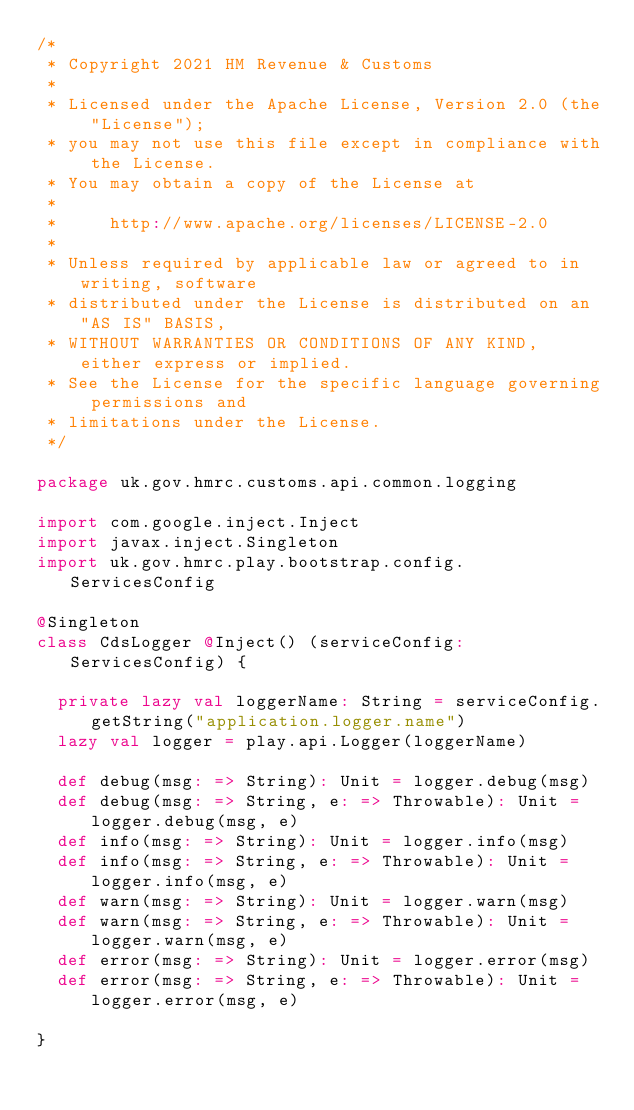<code> <loc_0><loc_0><loc_500><loc_500><_Scala_>/*
 * Copyright 2021 HM Revenue & Customs
 *
 * Licensed under the Apache License, Version 2.0 (the "License");
 * you may not use this file except in compliance with the License.
 * You may obtain a copy of the License at
 *
 *     http://www.apache.org/licenses/LICENSE-2.0
 *
 * Unless required by applicable law or agreed to in writing, software
 * distributed under the License is distributed on an "AS IS" BASIS,
 * WITHOUT WARRANTIES OR CONDITIONS OF ANY KIND, either express or implied.
 * See the License for the specific language governing permissions and
 * limitations under the License.
 */

package uk.gov.hmrc.customs.api.common.logging

import com.google.inject.Inject
import javax.inject.Singleton
import uk.gov.hmrc.play.bootstrap.config.ServicesConfig

@Singleton
class CdsLogger @Inject() (serviceConfig: ServicesConfig) {

  private lazy val loggerName: String = serviceConfig.getString("application.logger.name")
  lazy val logger = play.api.Logger(loggerName)

  def debug(msg: => String): Unit = logger.debug(msg)
  def debug(msg: => String, e: => Throwable): Unit = logger.debug(msg, e)
  def info(msg: => String): Unit = logger.info(msg)
  def info(msg: => String, e: => Throwable): Unit = logger.info(msg, e)
  def warn(msg: => String): Unit = logger.warn(msg)
  def warn(msg: => String, e: => Throwable): Unit = logger.warn(msg, e)
  def error(msg: => String): Unit = logger.error(msg)
  def error(msg: => String, e: => Throwable): Unit = logger.error(msg, e)

}
</code> 